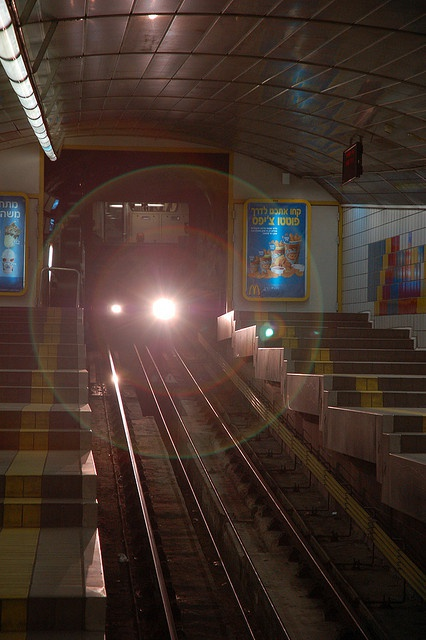Describe the objects in this image and their specific colors. I can see a train in lightgray, maroon, brown, and black tones in this image. 